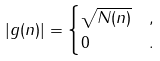<formula> <loc_0><loc_0><loc_500><loc_500>| g ( n ) | & = \begin{cases} \sqrt { N ( n ) } & , \\ 0 & . \end{cases}</formula> 